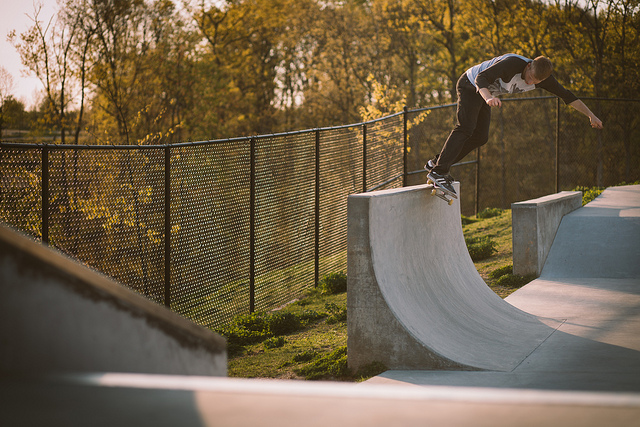How many people are there? 1 